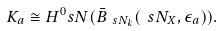Convert formula to latex. <formula><loc_0><loc_0><loc_500><loc_500>K _ { a } \cong H ^ { 0 } _ { \ } s N ( \bar { B } _ { \ s N _ { k } } ( \ s N _ { X } , \epsilon _ { a } ) ) .</formula> 